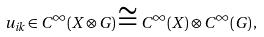<formula> <loc_0><loc_0><loc_500><loc_500>u _ { i k } \in C ^ { \infty } ( X \otimes G ) \cong C ^ { \infty } ( X ) \otimes C ^ { \infty } ( G ) \, ,</formula> 